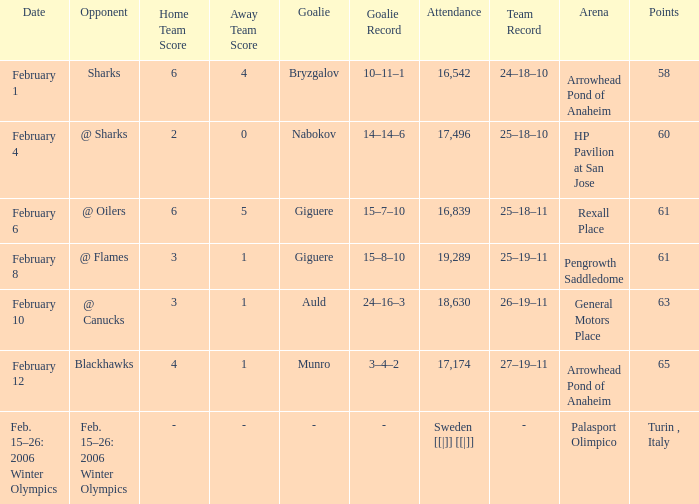What is the history when the score was 2-0? 25–18–10. 